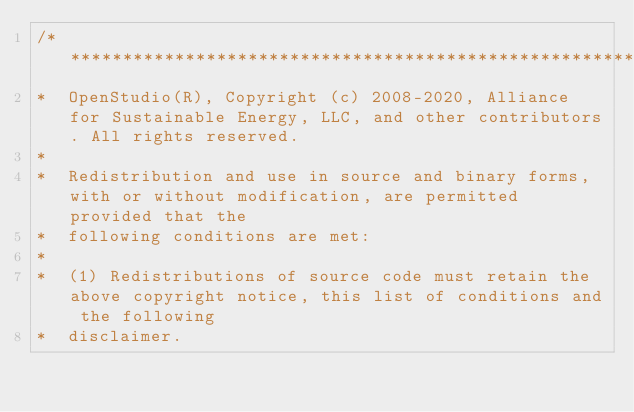<code> <loc_0><loc_0><loc_500><loc_500><_C++_>/***********************************************************************************************************************
*  OpenStudio(R), Copyright (c) 2008-2020, Alliance for Sustainable Energy, LLC, and other contributors. All rights reserved.
*
*  Redistribution and use in source and binary forms, with or without modification, are permitted provided that the
*  following conditions are met:
*
*  (1) Redistributions of source code must retain the above copyright notice, this list of conditions and the following
*  disclaimer.</code> 